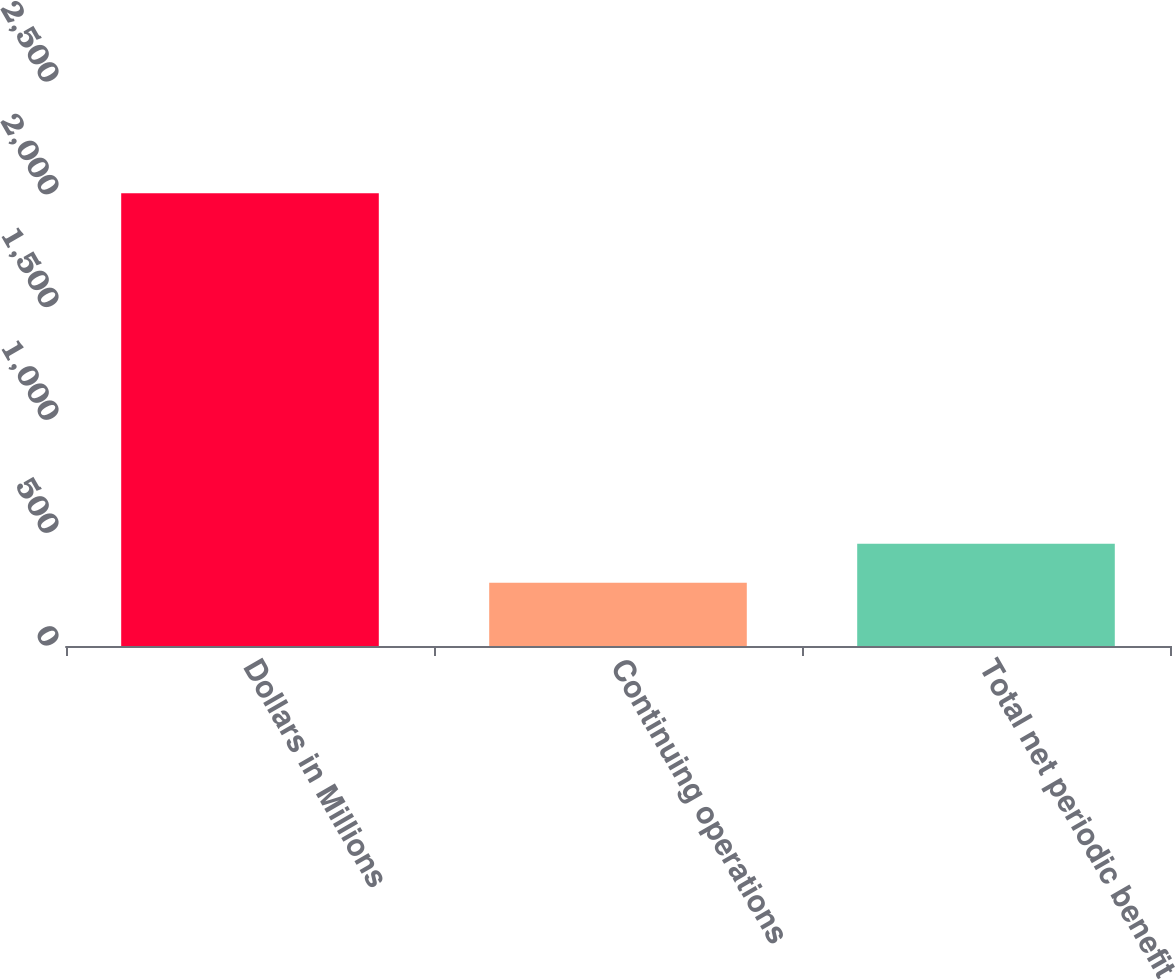Convert chart. <chart><loc_0><loc_0><loc_500><loc_500><bar_chart><fcel>Dollars in Millions<fcel>Continuing operations<fcel>Total net periodic benefit<nl><fcel>2007<fcel>280<fcel>452.7<nl></chart> 